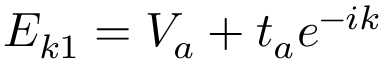<formula> <loc_0><loc_0><loc_500><loc_500>E _ { k 1 } = V _ { a } + t _ { a } e ^ { - i k }</formula> 